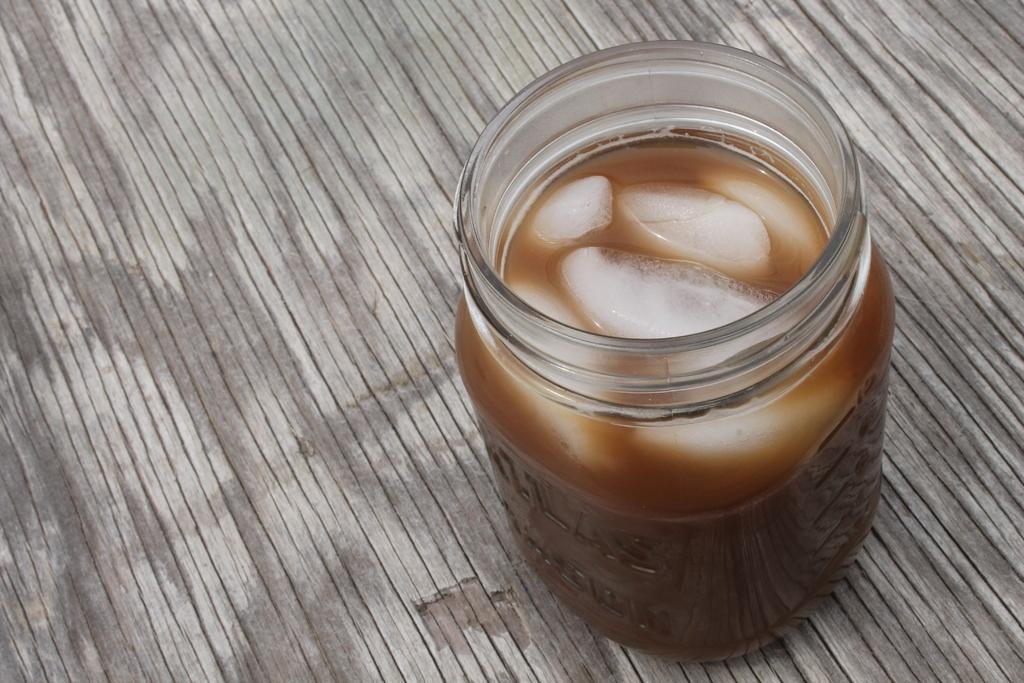In one or two sentences, can you explain what this image depicts? In this image I can see a jar and in it I can see few ice pieces. I can also see brown colour thing in it. 